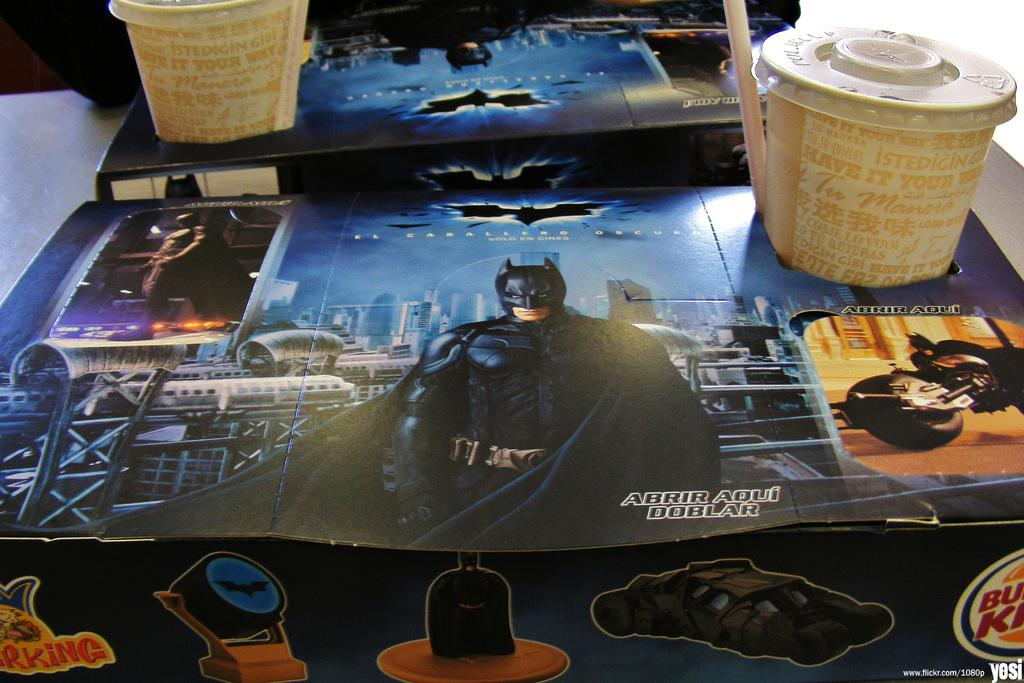How many cups are visible in the image? There are two cups in the image. What feature do the cups have in common? The cups have lids and straws. Where is the cup holder located in the image? The cup holder is on a table in the image. What type of fog can be seen surrounding the cups in the image? There is no fog present in the image; it is a clear scene with two cups, cup holders, and a table. 